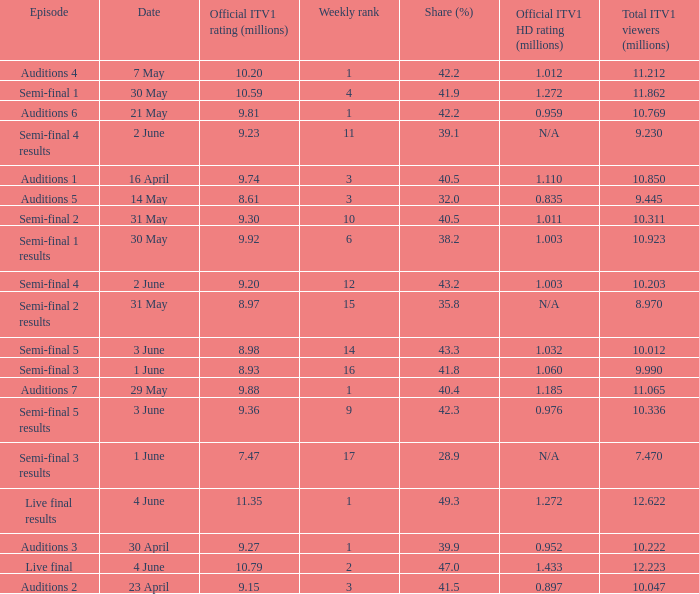What was the total ITV1 viewers in millions for the episode with a share (%) of 28.9?  7.47. Help me parse the entirety of this table. {'header': ['Episode', 'Date', 'Official ITV1 rating (millions)', 'Weekly rank', 'Share (%)', 'Official ITV1 HD rating (millions)', 'Total ITV1 viewers (millions)'], 'rows': [['Auditions 4', '7 May', '10.20', '1', '42.2', '1.012', '11.212'], ['Semi-final 1', '30 May', '10.59', '4', '41.9', '1.272', '11.862'], ['Auditions 6', '21 May', '9.81', '1', '42.2', '0.959', '10.769'], ['Semi-final 4 results', '2 June', '9.23', '11', '39.1', 'N/A', '9.230'], ['Auditions 1', '16 April', '9.74', '3', '40.5', '1.110', '10.850'], ['Auditions 5', '14 May', '8.61', '3', '32.0', '0.835', '9.445'], ['Semi-final 2', '31 May', '9.30', '10', '40.5', '1.011', '10.311'], ['Semi-final 1 results', '30 May', '9.92', '6', '38.2', '1.003', '10.923'], ['Semi-final 4', '2 June', '9.20', '12', '43.2', '1.003', '10.203'], ['Semi-final 2 results', '31 May', '8.97', '15', '35.8', 'N/A', '8.970'], ['Semi-final 5', '3 June', '8.98', '14', '43.3', '1.032', '10.012'], ['Semi-final 3', '1 June', '8.93', '16', '41.8', '1.060', '9.990'], ['Auditions 7', '29 May', '9.88', '1', '40.4', '1.185', '11.065'], ['Semi-final 5 results', '3 June', '9.36', '9', '42.3', '0.976', '10.336'], ['Semi-final 3 results', '1 June', '7.47', '17', '28.9', 'N/A', '7.470'], ['Live final results', '4 June', '11.35', '1', '49.3', '1.272', '12.622'], ['Auditions 3', '30 April', '9.27', '1', '39.9', '0.952', '10.222'], ['Live final', '4 June', '10.79', '2', '47.0', '1.433', '12.223'], ['Auditions 2', '23 April', '9.15', '3', '41.5', '0.897', '10.047']]} 